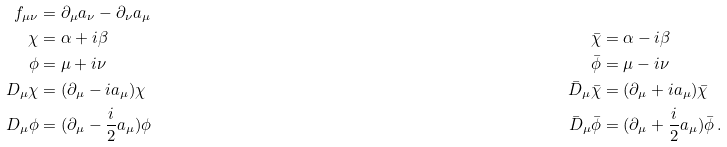<formula> <loc_0><loc_0><loc_500><loc_500>f _ { \mu \nu } & = \partial _ { \mu } a _ { \nu } - \partial _ { \nu } a _ { \mu } \\ \chi & = \alpha + i \beta & \bar { \chi } & = \alpha - i \beta \\ \phi & = \mu + i \nu & \bar { \phi } & = \mu - i \nu \\ D _ { \mu } \chi & = ( \partial _ { \mu } - i a _ { \mu } ) \chi & \bar { D } _ { \mu } \bar { \chi } & = ( \partial _ { \mu } + i a _ { \mu } ) \bar { \chi } \\ D _ { \mu } \phi & = ( \partial _ { \mu } - \frac { i } { 2 } a _ { \mu } ) \phi & \bar { D } _ { \mu } \bar { \phi } & = ( \partial _ { \mu } + \frac { i } { 2 } a _ { \mu } ) \bar { \phi } \, .</formula> 